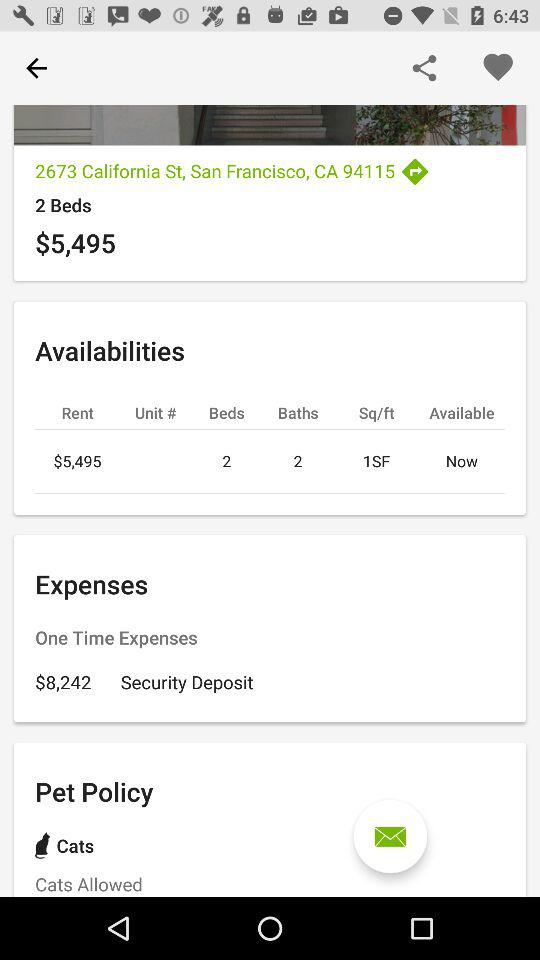What is the rent for a 2-bed? The rent is $5,495. 